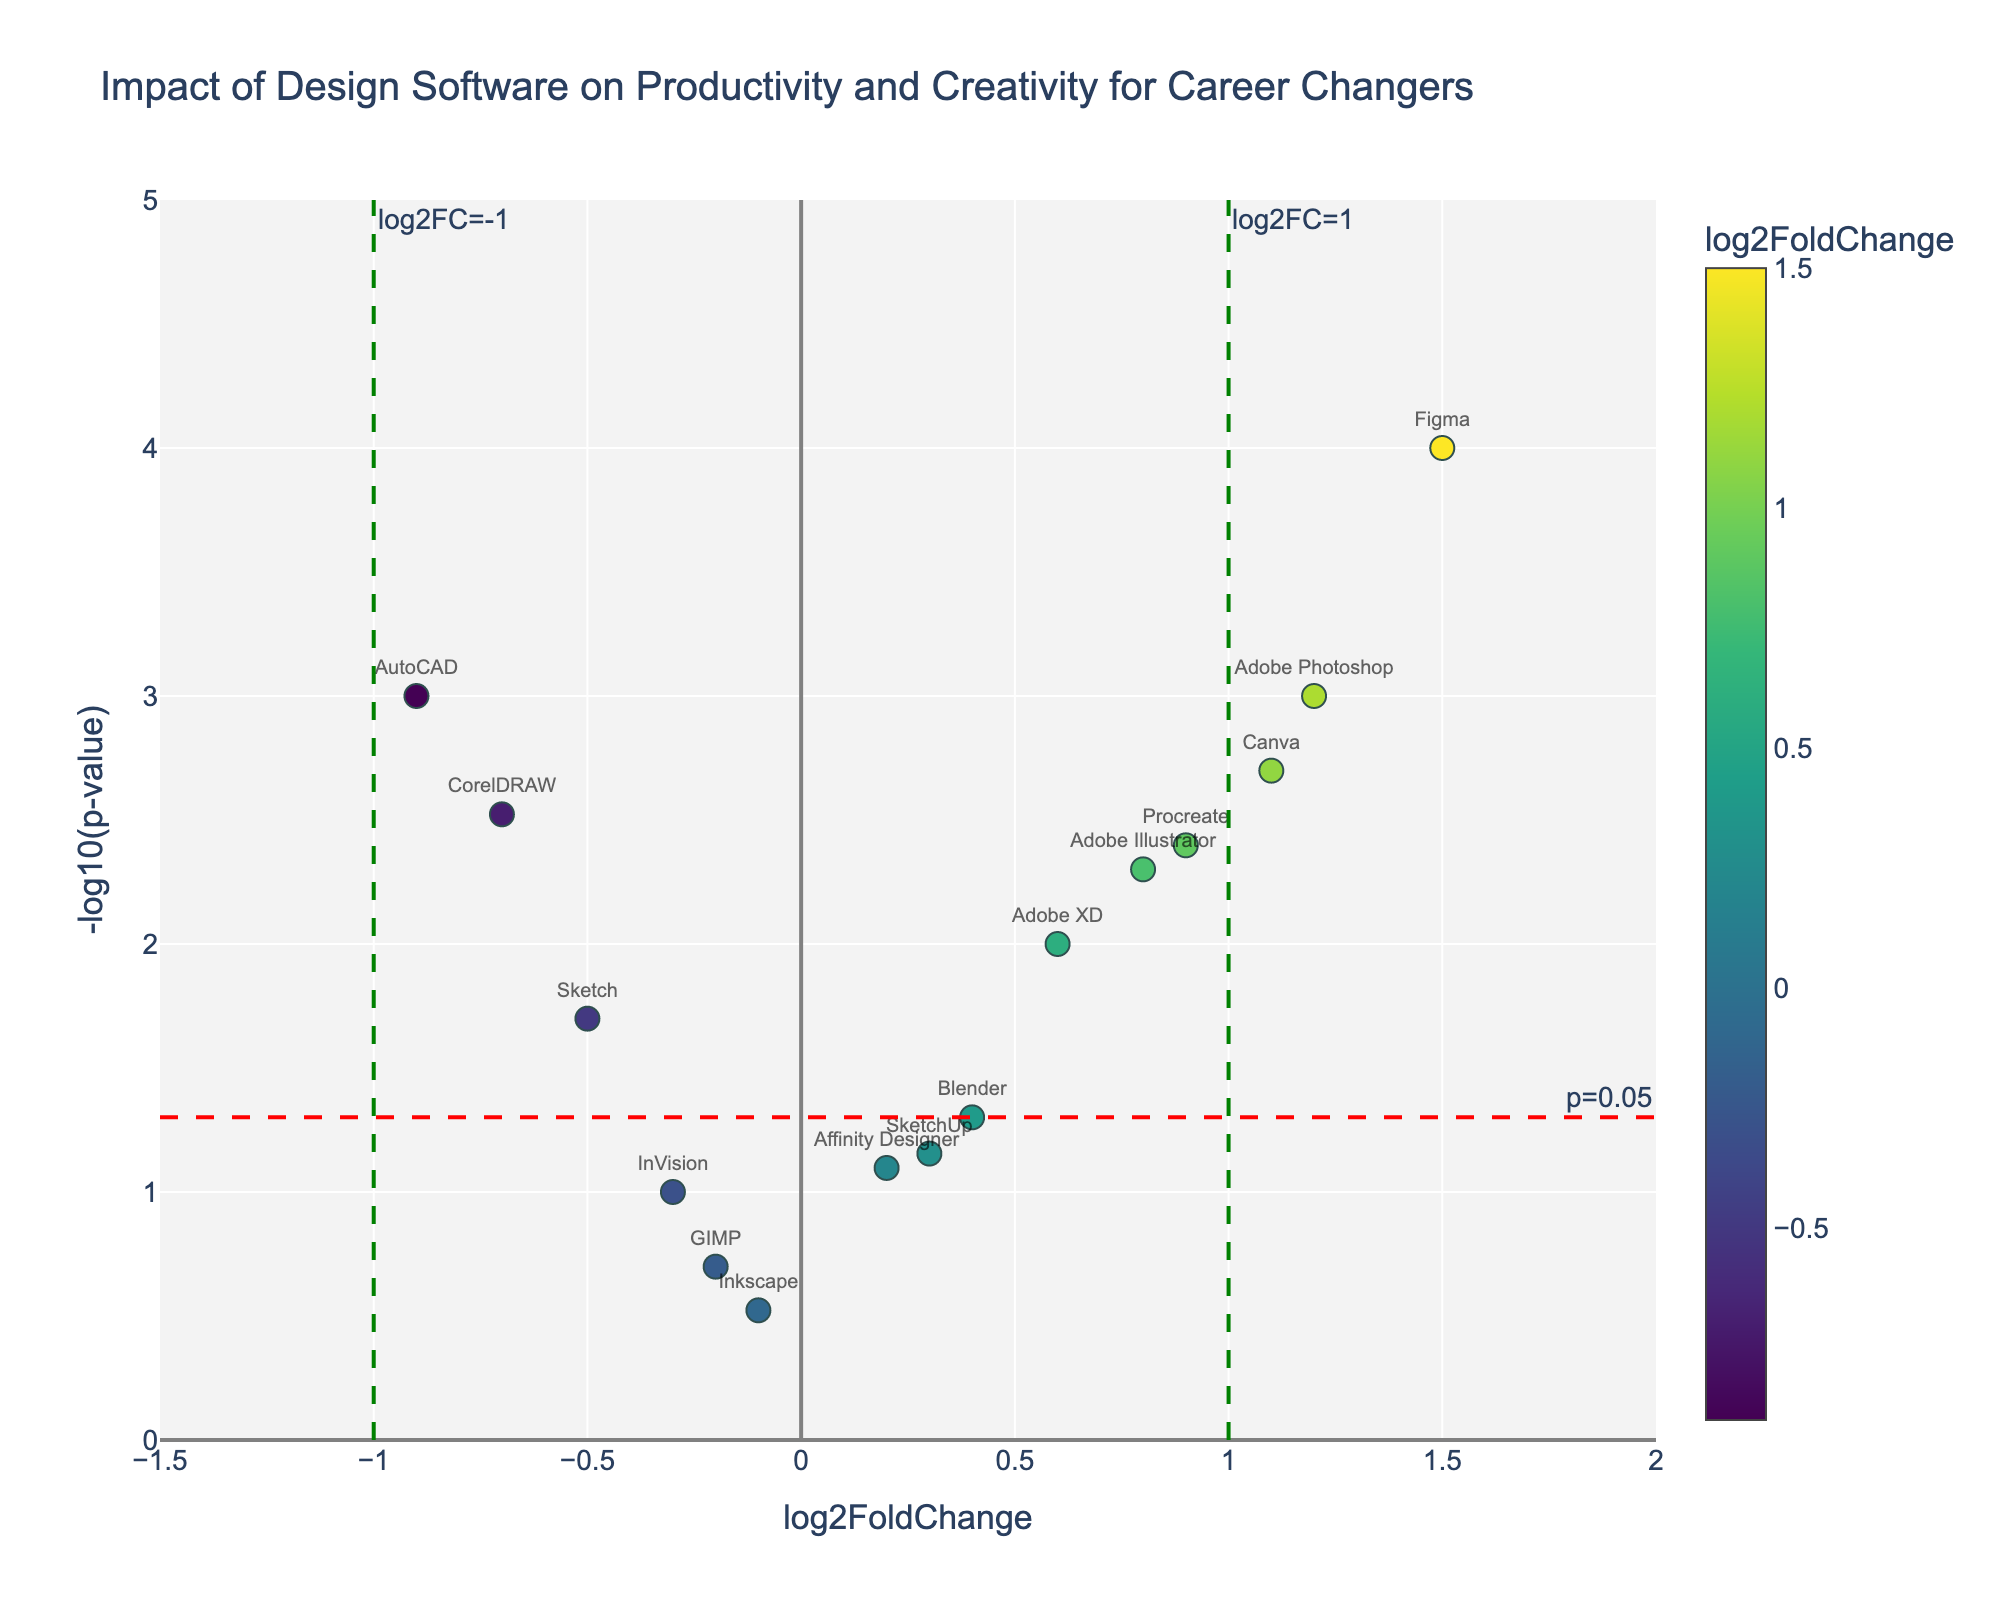What is the title of the plot? The title is at the top of the plot and indicates the focus of the data being presented. It reads "Impact of Design Software on Productivity and Creativity for Career Changers".
Answer: Impact of Design Software on Productivity and Creativity for Career Changers How many data points represent design software with a p-value less than 0.05? Look at the y-axis where the -log10(p-value) is greater than 1.3 (since -log10(0.05) ≈ 1.3). Count the number of points above this threshold.
Answer: 8 Which software has the highest log2FoldChange? Locate the point farthest to the right on the x-axis. The software label associated with this point is "Figma".
Answer: Figma How many software show a negative impact on productivity and creativity metrics (log2FoldChange < 0)? Count the number of points to the left of zero on the x-axis.
Answer: 5 Which software has the smallest p-value? Locate the point with the highest -log10(p-value) value. The software label associated with this point is "Figma".
Answer: Figma Which software has a log2FoldChange of 0.4? Find the point on the x-axis at 0.4. The associated software label is "Blender".
Answer: Blender Compare the impact of Adobe XD and Canva in terms of log2FoldChange. Which one has a higher value? Identify the log2FoldChange values for both Adobe XD (0.6) and Canva (1.1). Since 1.1 is greater than 0.6, Canva has a higher impact.
Answer: Canva How many software show a significant impact (p-value < 0.05) and an effect size greater than 1? Look at the points above the threshold line of -log10(0.05) and to the right of the line at log2FoldChange = 1. Count these points (Figma).
Answer: 1 Which software has the closest log2FoldChange to zero but still shows a positive impact? Find the smallest positive log2FoldChange value. Affinity Designer has a log2FoldChange of 0.2, which is positive and closest to zero compared to other positive values.
Answer: Affinity Designer What are the threshold values for significance shown on the plot? Refer to the dashed lines. The horizontal line is at -log10(0.05) (~1.3) for p-value, and the vertical lines are at log2FoldChange of 1 and -1.
Answer: -log10(0.05), log2FoldChange = 1, -1 